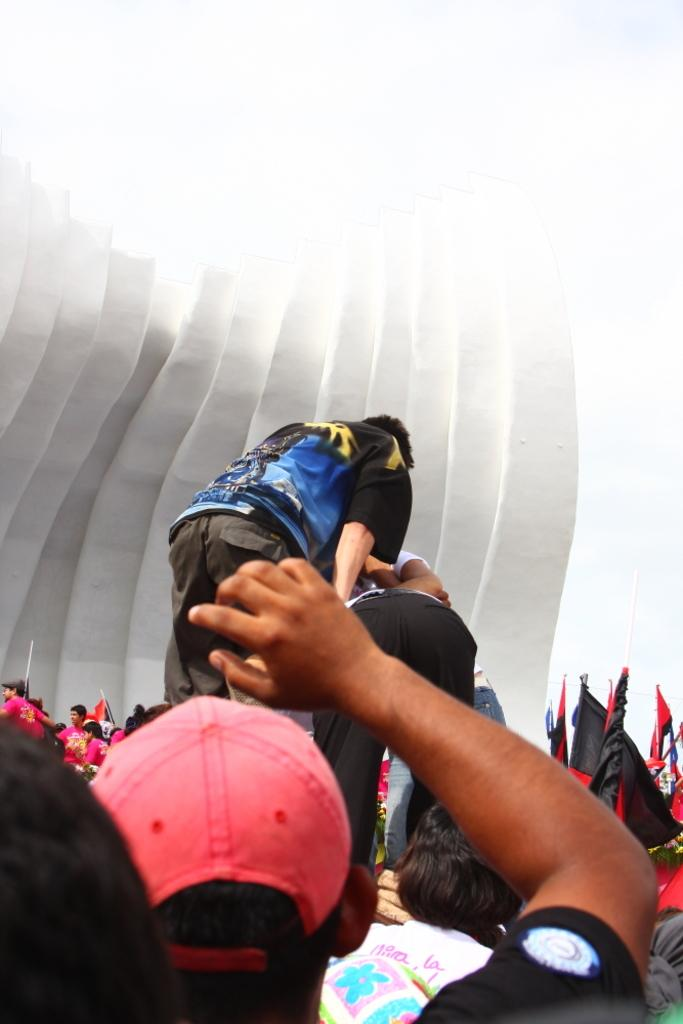Who or what can be seen at the bottom of the image? There are people at the bottom of the image. What is located on the right side of the image? There are flags on the right side of the image. What type of bell can be heard ringing in the image? There is no bell present in the image, so it is not possible to hear a bell ringing. 